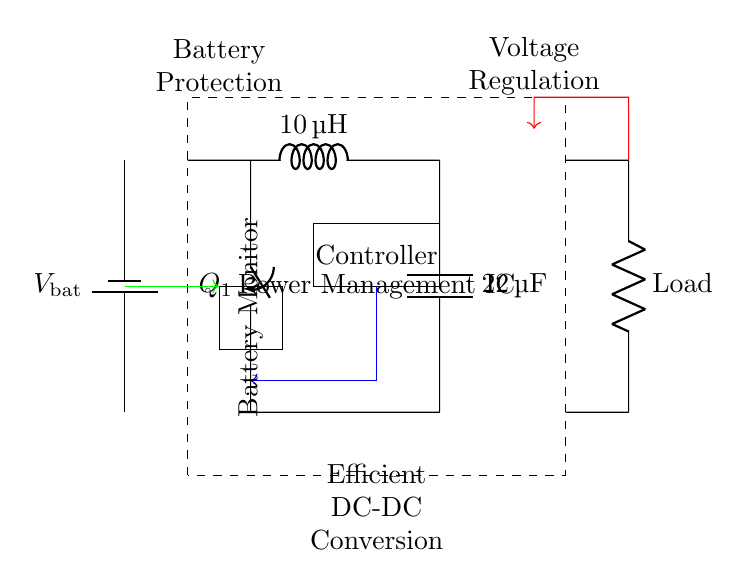What is the type of power management IC used in this circuit? The circuit includes a power management integrated circuit (IC) encased in a dashed rectangle with the label "Power Management IC." This indicates that it is a specialized chip designed to manage power consumption effectively.
Answer: Power Management IC What does the inductor value represent? The inductor labeled with a value of 10 microhenries is part of a buck converter, which indicates its role in energy storage and current smoothing during the conversion of voltage levels. The value affects the efficiency and ripple of the converter's output.
Answer: 10 microhenries What is the purpose of the controller in this circuit? The controller is responsible for regulating the behavior of the power management under different conditions, often adjusting the switching of the buck converter to maintain output voltage and prolong battery life. It is shown as a rectangle labeled "Controller."
Answer: Regulation From where is the load connected? The load is connected at point 7 on the right side of the circuit diagram, depicted by a resistor labeled "Load." This connection indicates where the output power is delivered to external equipment, relevant for veterinary operations.
Answer: Point 7 What role does the battery monitor play in this circuit? The battery monitor, shown in a rectangle and indicated by the label "Battery Monitor," is crucial for monitoring the battery's voltage and ensuring safe operation by preventing over-discharge or damage, enhancing battery longevity for the equipment.
Answer: Safety monitoring How does feedback affect the circuit operation? Feedback in this circuit is indicated by the red arrow pointing from the load back towards the controller. It is a crucial component of a control loop that sends voltage information back to the controller to maintain stable output voltage despite varying load conditions, ensuring consistent performance of veterinary equipment.
Answer: Stable output voltage 